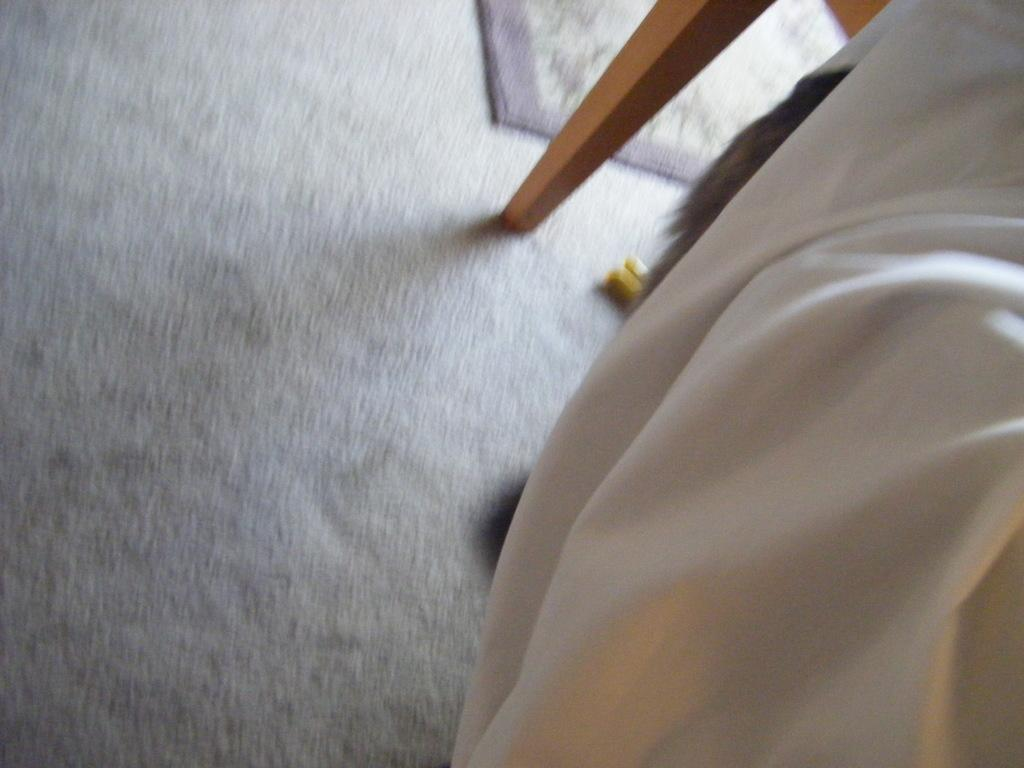What type of material is present in the image? There is cloth in the image. What can be found on the floor in the image? There is a mat on the floor in the image. What else is visible in the image besides the cloth and mat? There are objects in the image. Who is the manager of the butter in the image? There is no butter or manager present in the image. What type of crush can be seen on the cloth in the image? There is no crush present on the cloth in the image. 